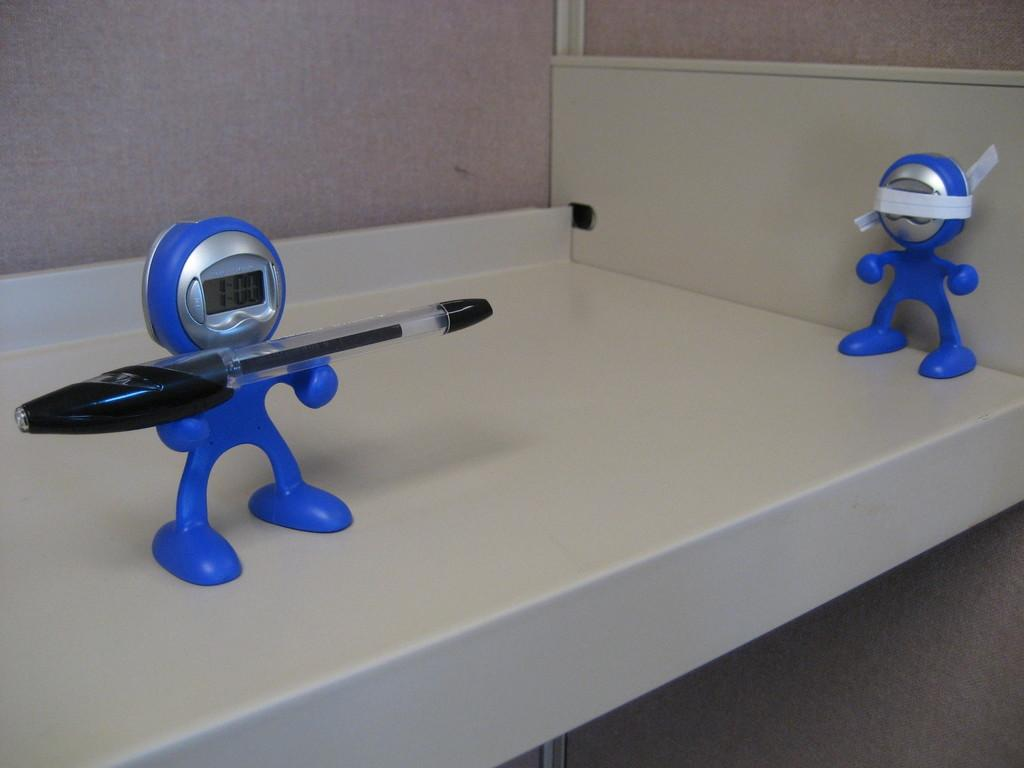What is the main object in the image? There is a cupboard rack in the image. What is placed on the cupboard rack? There are toy watches on the cupboard rack. Can you describe any additional details about the toy watches? There is a pen on one of the toy watches. What can be seen in the background of the image? There is a wall visible in the background of the image. How many basketballs can be seen hanging from the veins in the image? There are no basketballs or veins present in the image. 